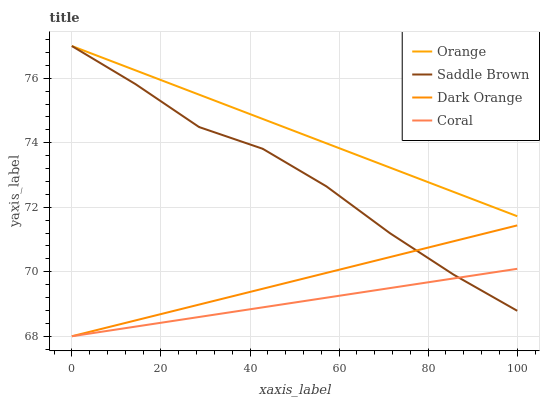Does Coral have the minimum area under the curve?
Answer yes or no. Yes. Does Orange have the maximum area under the curve?
Answer yes or no. Yes. Does Dark Orange have the minimum area under the curve?
Answer yes or no. No. Does Dark Orange have the maximum area under the curve?
Answer yes or no. No. Is Dark Orange the smoothest?
Answer yes or no. Yes. Is Saddle Brown the roughest?
Answer yes or no. Yes. Is Coral the smoothest?
Answer yes or no. No. Is Coral the roughest?
Answer yes or no. No. Does Saddle Brown have the lowest value?
Answer yes or no. No. Does Dark Orange have the highest value?
Answer yes or no. No. Is Coral less than Orange?
Answer yes or no. Yes. Is Orange greater than Coral?
Answer yes or no. Yes. Does Coral intersect Orange?
Answer yes or no. No. 